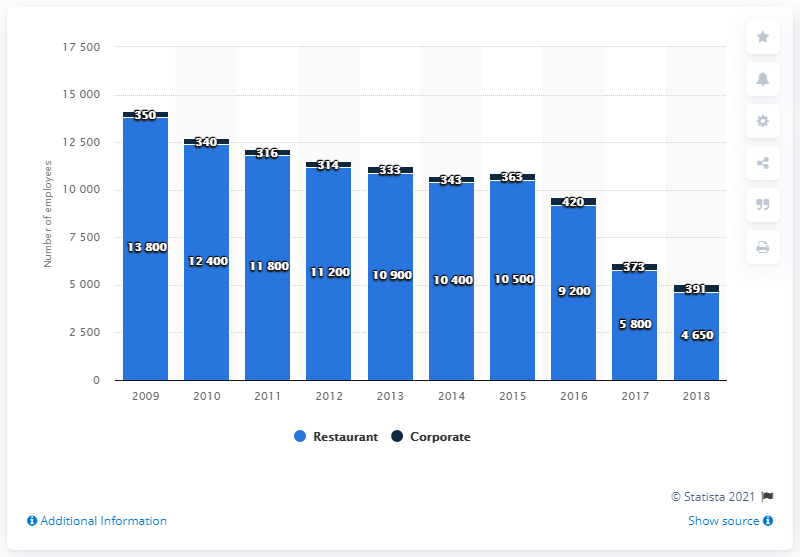Outline some significant characteristics in this image. In 2018, Sonic Corporation had a total of 391 corporate employees. In 2016, there were 420 corporate employees at Sonic Corporation. 